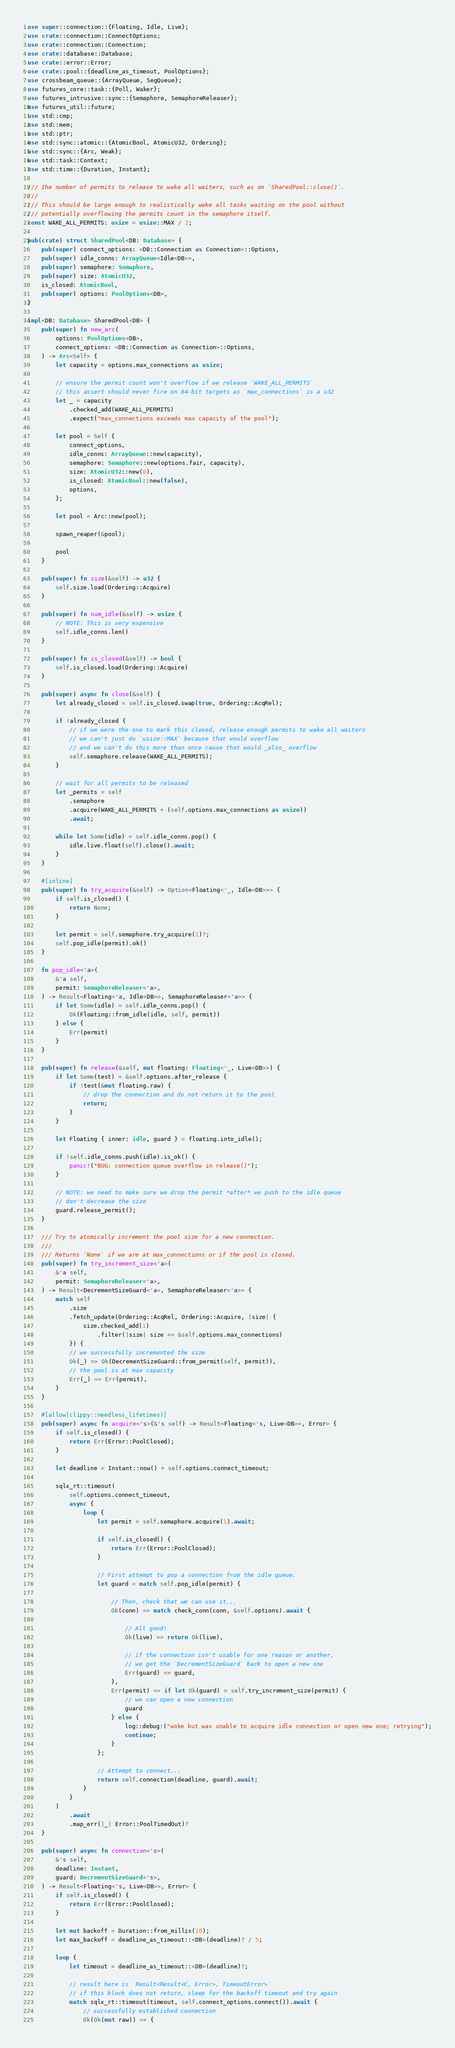Convert code to text. <code><loc_0><loc_0><loc_500><loc_500><_Rust_>use super::connection::{Floating, Idle, Live};
use crate::connection::ConnectOptions;
use crate::connection::Connection;
use crate::database::Database;
use crate::error::Error;
use crate::pool::{deadline_as_timeout, PoolOptions};
use crossbeam_queue::{ArrayQueue, SegQueue};
use futures_core::task::{Poll, Waker};
use futures_intrusive::sync::{Semaphore, SemaphoreReleaser};
use futures_util::future;
use std::cmp;
use std::mem;
use std::ptr;
use std::sync::atomic::{AtomicBool, AtomicU32, Ordering};
use std::sync::{Arc, Weak};
use std::task::Context;
use std::time::{Duration, Instant};

/// Ihe number of permits to release to wake all waiters, such as on `SharedPool::close()`.
///
/// This should be large enough to realistically wake all tasks waiting on the pool without
/// potentially overflowing the permits count in the semaphore itself.
const WAKE_ALL_PERMITS: usize = usize::MAX / 2;

pub(crate) struct SharedPool<DB: Database> {
    pub(super) connect_options: <DB::Connection as Connection>::Options,
    pub(super) idle_conns: ArrayQueue<Idle<DB>>,
    pub(super) semaphore: Semaphore,
    pub(super) size: AtomicU32,
    is_closed: AtomicBool,
    pub(super) options: PoolOptions<DB>,
}

impl<DB: Database> SharedPool<DB> {
    pub(super) fn new_arc(
        options: PoolOptions<DB>,
        connect_options: <DB::Connection as Connection>::Options,
    ) -> Arc<Self> {
        let capacity = options.max_connections as usize;

        // ensure the permit count won't overflow if we release `WAKE_ALL_PERMITS`
        // this assert should never fire on 64-bit targets as `max_connections` is a u32
        let _ = capacity
            .checked_add(WAKE_ALL_PERMITS)
            .expect("max_connections exceeds max capacity of the pool");

        let pool = Self {
            connect_options,
            idle_conns: ArrayQueue::new(capacity),
            semaphore: Semaphore::new(options.fair, capacity),
            size: AtomicU32::new(0),
            is_closed: AtomicBool::new(false),
            options,
        };

        let pool = Arc::new(pool);

        spawn_reaper(&pool);

        pool
    }

    pub(super) fn size(&self) -> u32 {
        self.size.load(Ordering::Acquire)
    }

    pub(super) fn num_idle(&self) -> usize {
        // NOTE: This is very expensive
        self.idle_conns.len()
    }

    pub(super) fn is_closed(&self) -> bool {
        self.is_closed.load(Ordering::Acquire)
    }

    pub(super) async fn close(&self) {
        let already_closed = self.is_closed.swap(true, Ordering::AcqRel);

        if !already_closed {
            // if we were the one to mark this closed, release enough permits to wake all waiters
            // we can't just do `usize::MAX` because that would overflow
            // and we can't do this more than once cause that would _also_ overflow
            self.semaphore.release(WAKE_ALL_PERMITS);
        }

        // wait for all permits to be released
        let _permits = self
            .semaphore
            .acquire(WAKE_ALL_PERMITS + (self.options.max_connections as usize))
            .await;

        while let Some(idle) = self.idle_conns.pop() {
            idle.live.float(self).close().await;
        }
    }

    #[inline]
    pub(super) fn try_acquire(&self) -> Option<Floating<'_, Idle<DB>>> {
        if self.is_closed() {
            return None;
        }

        let permit = self.semaphore.try_acquire(1)?;
        self.pop_idle(permit).ok()
    }

    fn pop_idle<'a>(
        &'a self,
        permit: SemaphoreReleaser<'a>,
    ) -> Result<Floating<'a, Idle<DB>>, SemaphoreReleaser<'a>> {
        if let Some(idle) = self.idle_conns.pop() {
            Ok(Floating::from_idle(idle, self, permit))
        } else {
            Err(permit)
        }
    }

    pub(super) fn release(&self, mut floating: Floating<'_, Live<DB>>) {
        if let Some(test) = &self.options.after_release {
            if !test(&mut floating.raw) {
                // drop the connection and do not return it to the pool
                return;
            }
        }

        let Floating { inner: idle, guard } = floating.into_idle();

        if !self.idle_conns.push(idle).is_ok() {
            panic!("BUG: connection queue overflow in release()");
        }

        // NOTE: we need to make sure we drop the permit *after* we push to the idle queue
        // don't decrease the size
        guard.release_permit();
    }

    /// Try to atomically increment the pool size for a new connection.
    ///
    /// Returns `None` if we are at max_connections or if the pool is closed.
    pub(super) fn try_increment_size<'a>(
        &'a self,
        permit: SemaphoreReleaser<'a>,
    ) -> Result<DecrementSizeGuard<'a>, SemaphoreReleaser<'a>> {
        match self
            .size
            .fetch_update(Ordering::AcqRel, Ordering::Acquire, |size| {
                size.checked_add(1)
                    .filter(|size| size <= &self.options.max_connections)
            }) {
            // we successfully incremented the size
            Ok(_) => Ok(DecrementSizeGuard::from_permit(self, permit)),
            // the pool is at max capacity
            Err(_) => Err(permit),
        }
    }

    #[allow(clippy::needless_lifetimes)]
    pub(super) async fn acquire<'s>(&'s self) -> Result<Floating<'s, Live<DB>>, Error> {
        if self.is_closed() {
            return Err(Error::PoolClosed);
        }

        let deadline = Instant::now() + self.options.connect_timeout;

        sqlx_rt::timeout(
            self.options.connect_timeout,
            async {
                loop {
                    let permit = self.semaphore.acquire(1).await;

                    if self.is_closed() {
                        return Err(Error::PoolClosed);
                    }

                    // First attempt to pop a connection from the idle queue.
                    let guard = match self.pop_idle(permit) {

                        // Then, check that we can use it...
                        Ok(conn) => match check_conn(conn, &self.options).await {

                            // All good!
                            Ok(live) => return Ok(live),

                            // if the connection isn't usable for one reason or another,
                            // we get the `DecrementSizeGuard` back to open a new one
                            Err(guard) => guard,
                        },
                        Err(permit) => if let Ok(guard) = self.try_increment_size(permit) {
                            // we can open a new connection
                            guard
                        } else {
                            log::debug!("woke but was unable to acquire idle connection or open new one; retrying");
                            continue;
                        }
                    };

                    // Attempt to connect...
                    return self.connection(deadline, guard).await;
                }
            }
        )
            .await
            .map_err(|_| Error::PoolTimedOut)?
    }

    pub(super) async fn connection<'s>(
        &'s self,
        deadline: Instant,
        guard: DecrementSizeGuard<'s>,
    ) -> Result<Floating<'s, Live<DB>>, Error> {
        if self.is_closed() {
            return Err(Error::PoolClosed);
        }

        let mut backoff = Duration::from_millis(10);
        let max_backoff = deadline_as_timeout::<DB>(deadline)? / 5;

        loop {
            let timeout = deadline_as_timeout::<DB>(deadline)?;

            // result here is `Result<Result<C, Error>, TimeoutError>`
            // if this block does not return, sleep for the backoff timeout and try again
            match sqlx_rt::timeout(timeout, self.connect_options.connect()).await {
                // successfully established connection
                Ok(Ok(mut raw)) => {</code> 